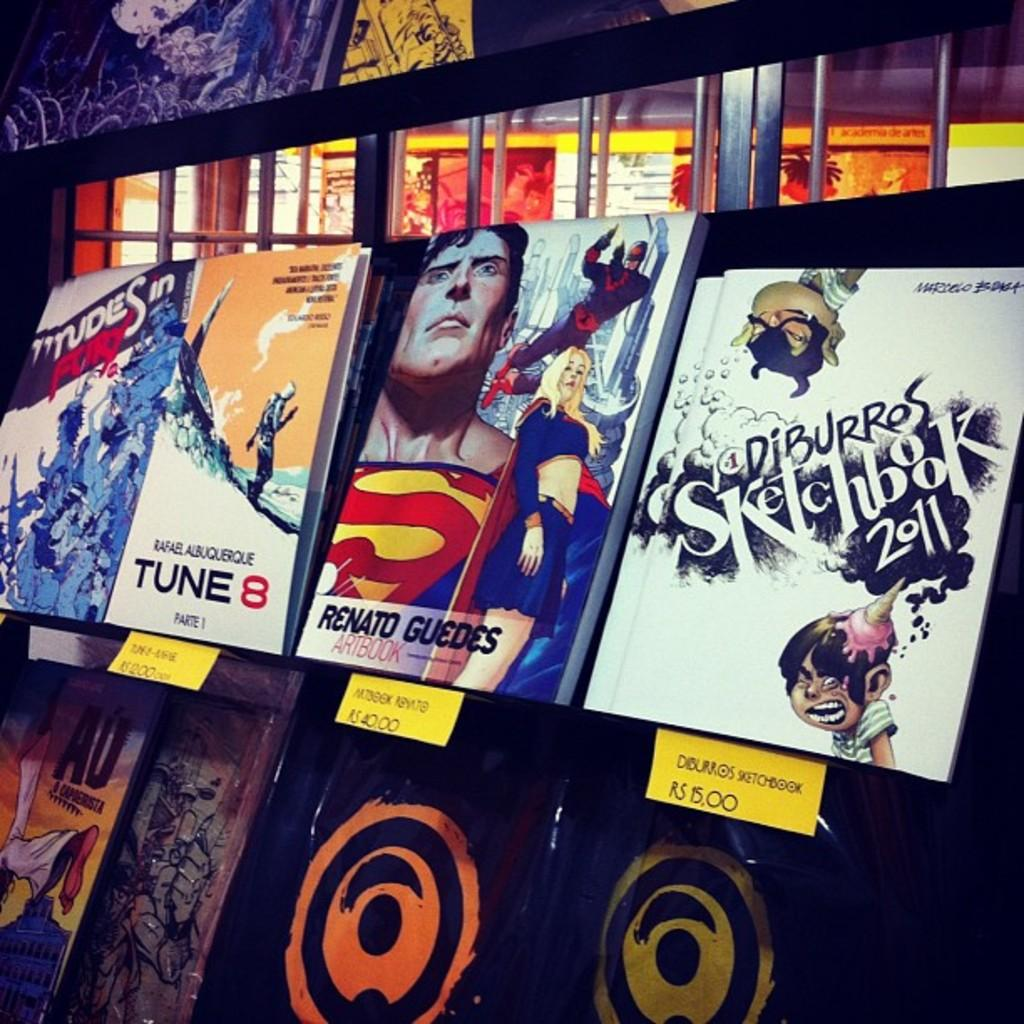Provide a one-sentence caption for the provided image. A Diburros Sketchbook 2011 comic book is displayed on a rack with other comic books. 